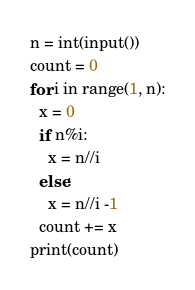Convert code to text. <code><loc_0><loc_0><loc_500><loc_500><_Python_>n = int(input())
count = 0
for i in range(1, n):
  x = 0
  if n%i:
    x = n//i
  else:
    x = n//i -1
  count += x
print(count)</code> 